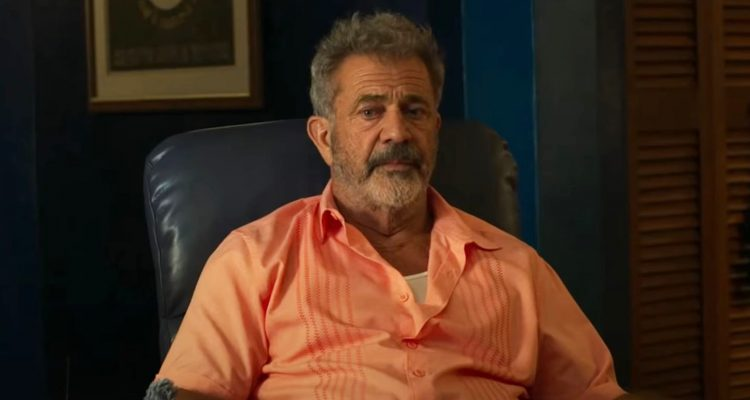If this image were part of a movie, what genre would it be and why? If this image were part of a movie, the genre would likely be a drama with elements of character study and introspection. The serious expression and contemplative pose of the character suggest deep personal involvement and a storyline that delves into the complexities of life, relationships, and individual purpose. The office-like setting adds a touch of professional and intellectual background, hinting at themes that explore the character’s past achievements and internal conflicts, making it a rich narrative ripe for emotional and philosophical exploration. Describe a key scene from this movie. A key scene from this movie could be set late in the evening, the room dimly lit by a single lamp on the desk. The character, John, sits silently in his blue leather chair, holding a book with a leather-bound cover. As he turns the pages, his eyes linger on a particular passage. Flashbacks reveal his younger days as a passionate professor, guiding his students through profound literary discussions. The camera shifts back to the present, where John’s eyes glisten with unshed tears. He closes the book gently, places it on his lap, and looks up at a framed photograph on the bookshelf – an old picture of him with a group of young students, all beaming with enthusiasm. This scene encapsulates the bittersweet blend of nostalgia, pride, and the inevitable passage of time, setting the tone for the movie's exploration of life's meaning and the lasting impact one can have on others. 